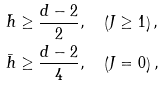Convert formula to latex. <formula><loc_0><loc_0><loc_500><loc_500>\bar { h } & \geq \frac { d - 2 } { 2 } , \quad \left ( J \geq 1 \right ) , \\ \bar { h } & \geq \frac { d - 2 } { 4 } , \quad \left ( J = 0 \right ) ,</formula> 